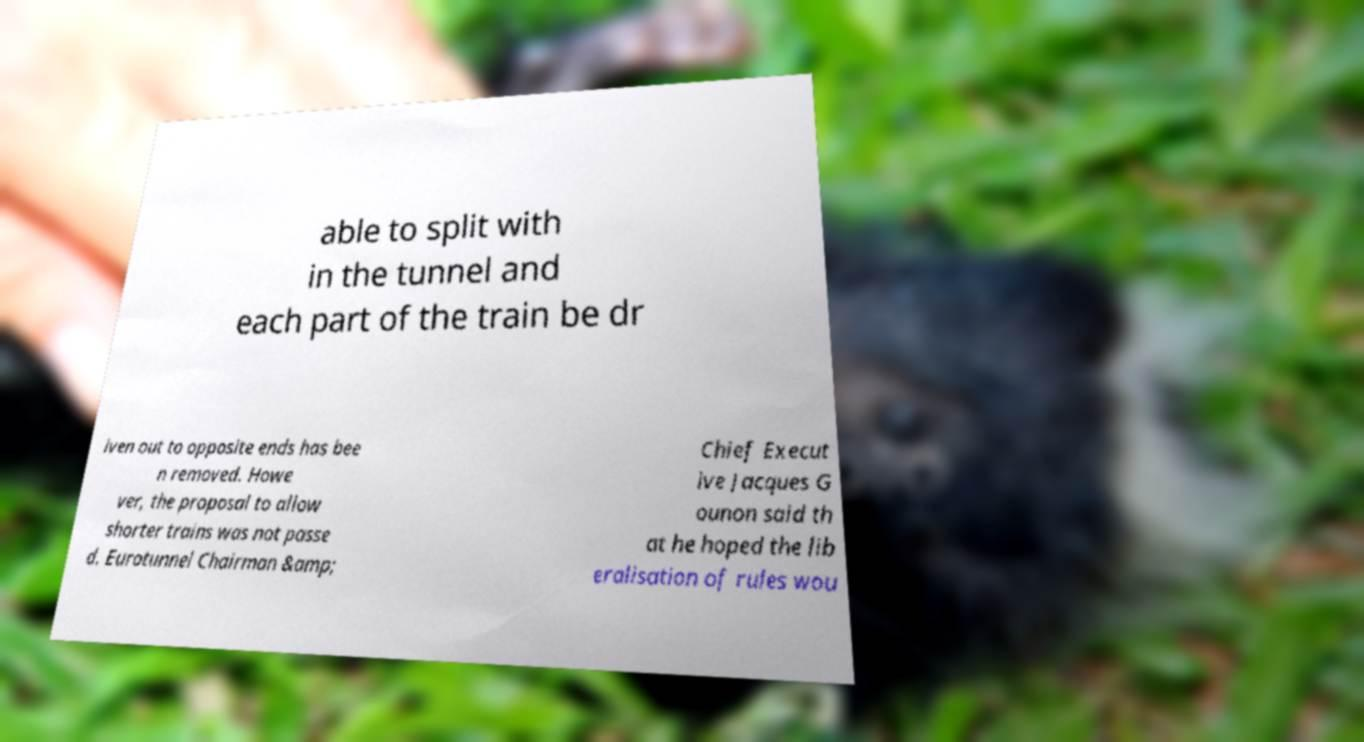Could you extract and type out the text from this image? able to split with in the tunnel and each part of the train be dr iven out to opposite ends has bee n removed. Howe ver, the proposal to allow shorter trains was not passe d. Eurotunnel Chairman &amp; Chief Execut ive Jacques G ounon said th at he hoped the lib eralisation of rules wou 